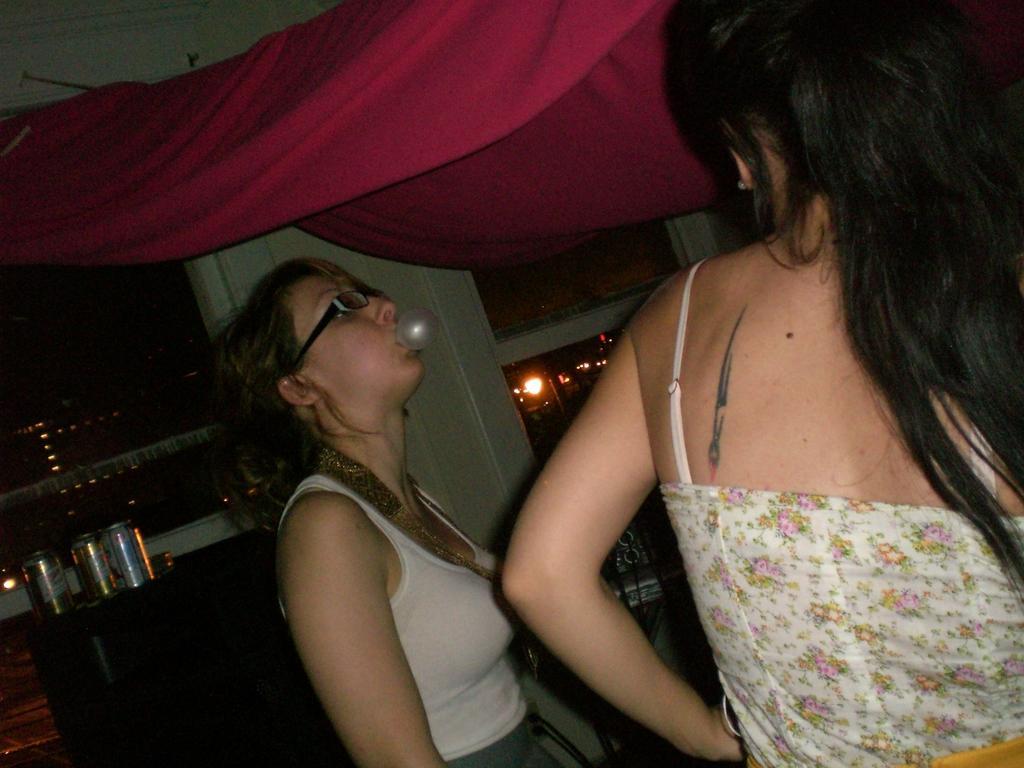Describe this image in one or two sentences. Here I can see two women. The woman who is on the right side is looking at the other woman. The other woman is eating the chewing gum. At the top of these women there is a cloth. In the background there is a pillar. In the background, I can see many objects and lights in the dark. 